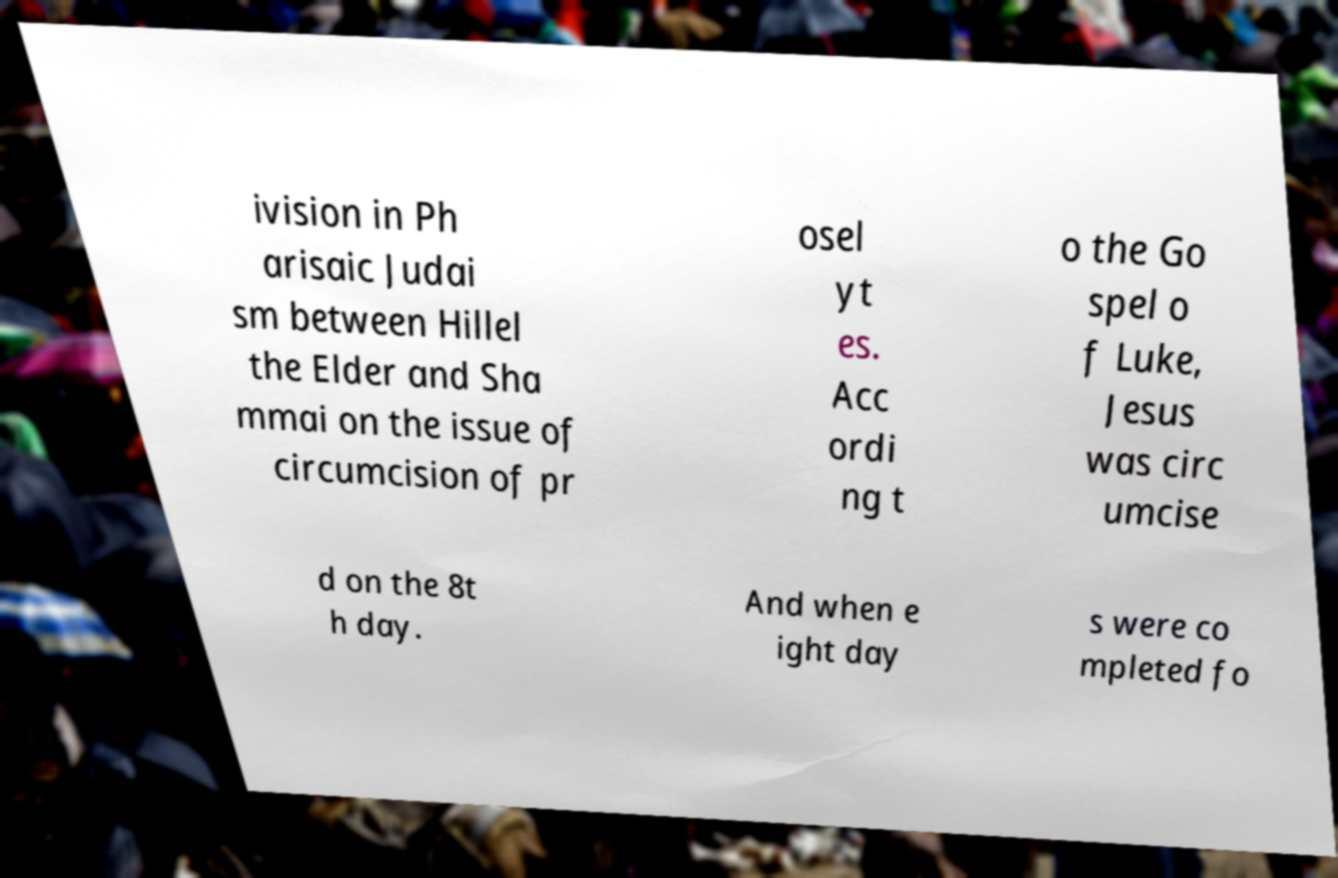Can you read and provide the text displayed in the image?This photo seems to have some interesting text. Can you extract and type it out for me? ivision in Ph arisaic Judai sm between Hillel the Elder and Sha mmai on the issue of circumcision of pr osel yt es. Acc ordi ng t o the Go spel o f Luke, Jesus was circ umcise d on the 8t h day. And when e ight day s were co mpleted fo 